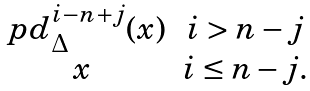Convert formula to latex. <formula><loc_0><loc_0><loc_500><loc_500>\begin{matrix} \ p d ^ { i - n + j } _ { \Delta } ( x ) & i > n - j \\ x & i \leq n - j . \end{matrix}</formula> 